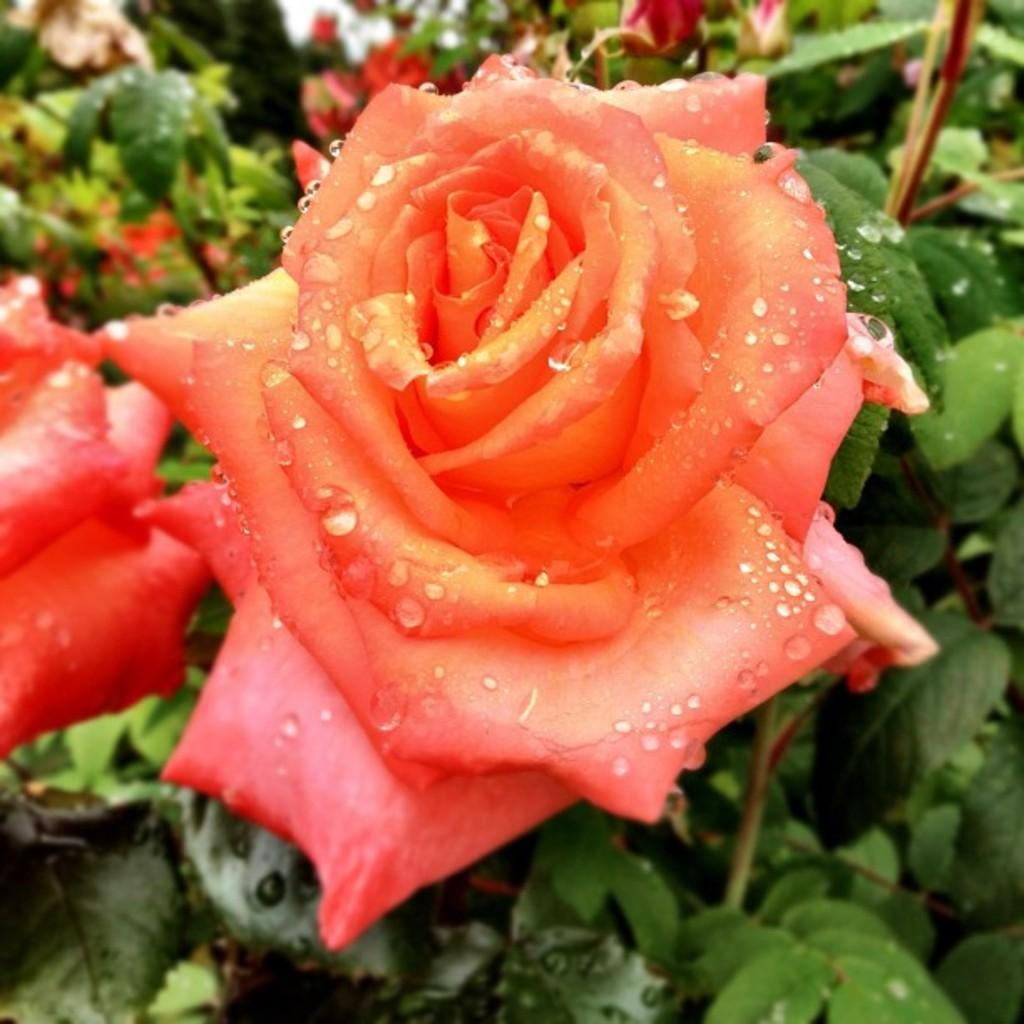What type of living organism is present in the image? There is a plant in the image. What specific part of the plant can be seen? The plant contains a rose. How many socks are visible on the plant in the image? There are no socks present in the image; it features a plant with a rose. 